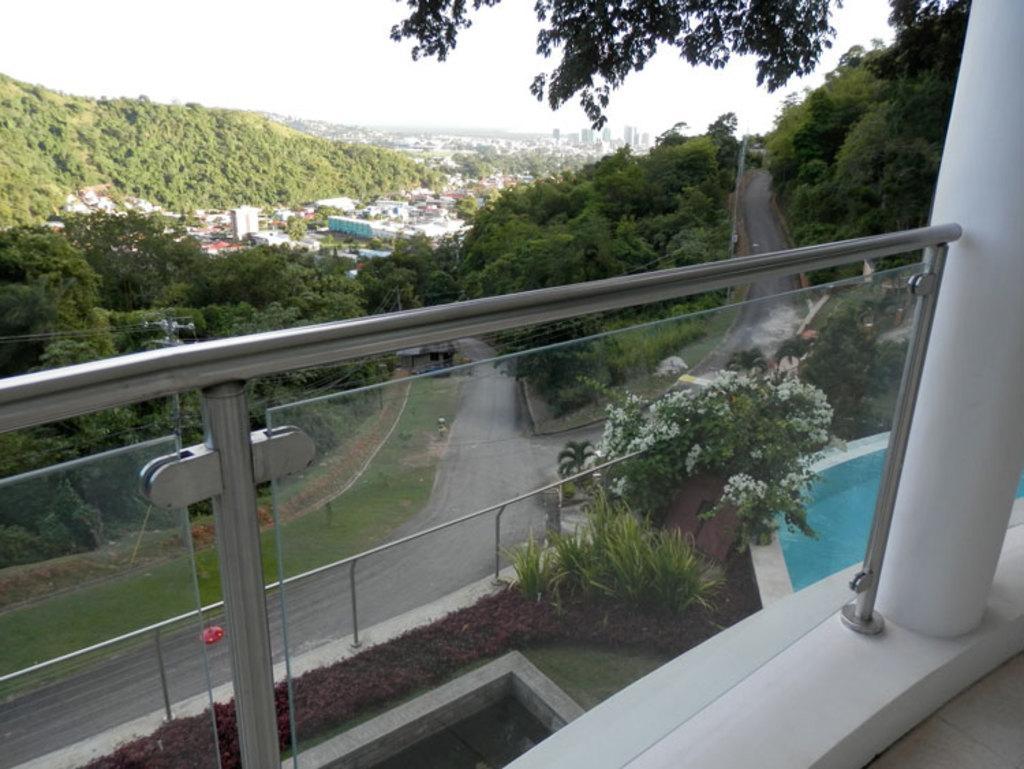How would you summarize this image in a sentence or two? In this image there is a balcony, in front of that there is a plant with flowers, road, trees and buildings. 